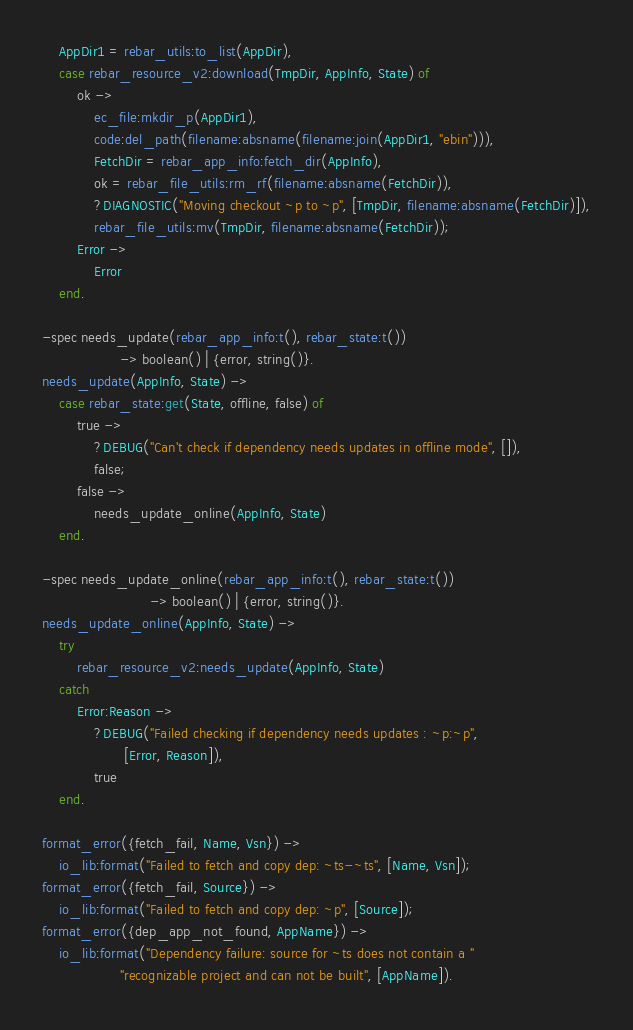Convert code to text. <code><loc_0><loc_0><loc_500><loc_500><_Erlang_>    AppDir1 = rebar_utils:to_list(AppDir),
    case rebar_resource_v2:download(TmpDir, AppInfo, State) of
        ok ->
            ec_file:mkdir_p(AppDir1),
            code:del_path(filename:absname(filename:join(AppDir1, "ebin"))),
            FetchDir = rebar_app_info:fetch_dir(AppInfo),
            ok = rebar_file_utils:rm_rf(filename:absname(FetchDir)),
            ?DIAGNOSTIC("Moving checkout ~p to ~p", [TmpDir, filename:absname(FetchDir)]),
            rebar_file_utils:mv(TmpDir, filename:absname(FetchDir));
        Error ->
            Error
    end.

-spec needs_update(rebar_app_info:t(), rebar_state:t())
                  -> boolean() | {error, string()}.
needs_update(AppInfo, State) ->
    case rebar_state:get(State, offline, false) of
        true ->
            ?DEBUG("Can't check if dependency needs updates in offline mode", []),
            false;
        false ->
            needs_update_online(AppInfo, State)
    end.

-spec needs_update_online(rebar_app_info:t(), rebar_state:t())
                         -> boolean() | {error, string()}.
needs_update_online(AppInfo, State) ->
    try
        rebar_resource_v2:needs_update(AppInfo, State)
    catch
        Error:Reason ->
            ?DEBUG("Failed checking if dependency needs updates : ~p:~p",
                   [Error, Reason]),
            true
    end.

format_error({fetch_fail, Name, Vsn}) ->
    io_lib:format("Failed to fetch and copy dep: ~ts-~ts", [Name, Vsn]);
format_error({fetch_fail, Source}) ->
    io_lib:format("Failed to fetch and copy dep: ~p", [Source]);
format_error({dep_app_not_found, AppName}) ->
    io_lib:format("Dependency failure: source for ~ts does not contain a "
                  "recognizable project and can not be built", [AppName]).
</code> 